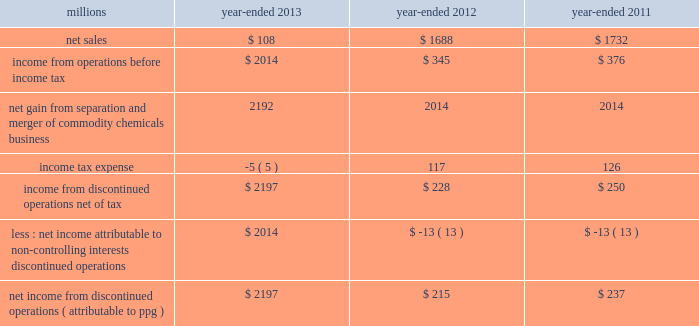74 2013 ppg annual report and form 10-k 22 .
Separation and merger transaction on january 28 , 2013 , the company completed the previously announced separation of its commodity chemicals business and merger of its wholly-owned subsidiary , eagle spinco inc. , with a subsidiary of georgia gulf corporation in a tax ef ficient reverse morris trust transaction ( the 201ctransaction 201d ) .
Pursuant to the merger , eagle spinco , the entity holding ppg's former commodity chemicals business , became a wholly-owned subsidiary of georgia gulf .
The closing of the merger followed the expiration of the related exchange offer and the satisfaction of certain other conditions .
The combined company formed by uniting georgia gulf with ppg's former commodity chemicals business is named axiall corporation ( 201caxiall 201d ) .
Ppg holds no ownership interest in axiall .
Ppg received the necessary ruling from the internal revenue service and as a result this transaction was generally tax free to ppg and its shareholders in the united states and canada .
Under the terms of the exchange offer , 35249104 shares of eagle spinco common stock were available for distribution in exchange for shares of ppg common stock accepted in the offer .
Following the merger , each share of eagle spinco common stock automatically converted into the right to receive one share of axiall corporation common stock .
Accordingly , ppg shareholders who tendered their shares of ppg common stock as part of this offer received 3.2562 shares of axiall common stock for each share of ppg common stock accepted for exchange .
Ppg was able to accept the maximum of 10825227 shares of ppg common stock for exchange in the offer , and thereby , reduced its outstanding shares by approximately 7% ( 7 % ) .
The completion of this exchange offer was a non-cash financing transaction , which resulted in an increase in "treasury stock" at a cost of $ 1.561 billion based on the ppg closing stock price on january 25 , 2013 .
Under the terms of the transaction , ppg received $ 900 million of cash and 35.2 million shares of axiall common stock ( market value of $ 1.8 billion on january 25 , 2013 ) which was distributed to ppg shareholders by the exchange offer as described above .
In addition , ppg received $ 67 million in cash for a preliminary post-closing working capital adjustment under the terms of the transaction agreements .
The net assets transferred to axiall included $ 27 million of cash on the books of the business transferred .
In the transaction , ppg transferred environmental remediation liabilities , defined benefit pension plan assets and liabilities and other post-employment benefit liabilities related to the commodity chemicals business to axiall .
During the first quarter of 2013 , ppg recorded a gain of $ 2.2 billion on the transaction reflecting the excess of the sum of the cash proceeds received and the cost ( closing stock price on january 25 , 2013 ) of the ppg shares tendered and accepted in the exchange for the 35.2 million shares of axiall common stock over the net book value of the net assets of ppg's former commodity chemicals business .
The transaction resulted in a net partial settlement loss of $ 33 million associated with the spin out and termination of defined benefit pension liabilities and the transfer of other post-retirement benefit liabilities under the terms of the transaction .
The company also incurred $ 14 million of pretax expense , primarily for professional services related to the transaction in 2013 as well as approximately $ 2 million of net expense related to certain retained obligations and post-closing adjustments under the terms of the transaction agreements .
The net gain on the transaction includes these related losses and expenses .
The results of operations and cash flows of ppg's former commodity chemicals business for january 2013 and the net gain on the transaction are reported as results from discontinued operations for the year -ended december 31 , 2013 .
In prior periods presented , the results of operations and cash flows of ppg's former commodity chemicals business have been reclassified from continuing operations and presented as results from discontinued operations .
Ppg will provide axiall with certain transition services for up to 24 months following the closing date of the transaction .
These services include logistics , purchasing , finance , information technology , human resources , tax and payroll processing .
The net sales and income before income taxes of the commodity chemicals business that have been reclassified and reported as discontinued operations are presented in the table below: .
Income from discontinued operations , net of tax $ 2197 $ 228 $ 250 less : net income attributable to non- controlling interests , discontinued operations $ 2014 $ ( 13 ) $ ( 13 ) net income from discontinued operations ( attributable to ppg ) $ 2197 $ 215 $ 237 during 2012 , $ 21 million of business separation costs are included within "income from discontinued operations , net." notes to the consolidated financial statements .
What was the change in millions of net sales for the commodity chemicals business that has been reclassified and reported as discontinued operations from 2012 to 2013? 
Computations: (108 - 1688)
Answer: -1580.0. 